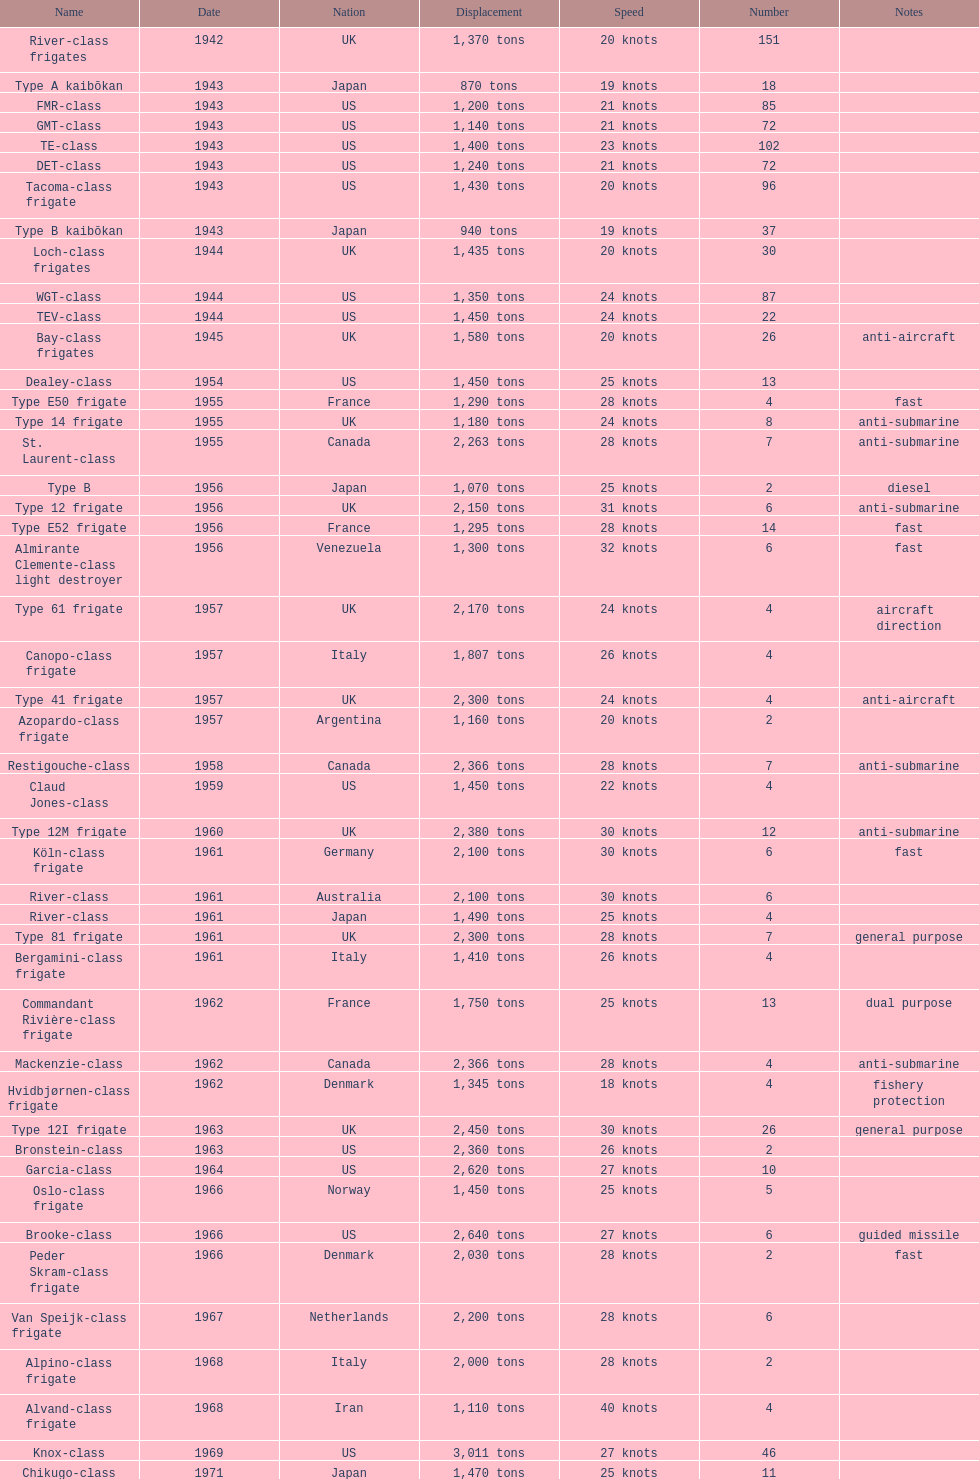Help me parse the entirety of this table. {'header': ['Name', 'Date', 'Nation', 'Displacement', 'Speed', 'Number', 'Notes'], 'rows': [['River-class frigates', '1942', 'UK', '1,370 tons', '20 knots', '151', ''], ['Type A kaibōkan', '1943', 'Japan', '870 tons', '19 knots', '18', ''], ['FMR-class', '1943', 'US', '1,200 tons', '21 knots', '85', ''], ['GMT-class', '1943', 'US', '1,140 tons', '21 knots', '72', ''], ['TE-class', '1943', 'US', '1,400 tons', '23 knots', '102', ''], ['DET-class', '1943', 'US', '1,240 tons', '21 knots', '72', ''], ['Tacoma-class frigate', '1943', 'US', '1,430 tons', '20 knots', '96', ''], ['Type B kaibōkan', '1943', 'Japan', '940 tons', '19 knots', '37', ''], ['Loch-class frigates', '1944', 'UK', '1,435 tons', '20 knots', '30', ''], ['WGT-class', '1944', 'US', '1,350 tons', '24 knots', '87', ''], ['TEV-class', '1944', 'US', '1,450 tons', '24 knots', '22', ''], ['Bay-class frigates', '1945', 'UK', '1,580 tons', '20 knots', '26', 'anti-aircraft'], ['Dealey-class', '1954', 'US', '1,450 tons', '25 knots', '13', ''], ['Type E50 frigate', '1955', 'France', '1,290 tons', '28 knots', '4', 'fast'], ['Type 14 frigate', '1955', 'UK', '1,180 tons', '24 knots', '8', 'anti-submarine'], ['St. Laurent-class', '1955', 'Canada', '2,263 tons', '28 knots', '7', 'anti-submarine'], ['Type B', '1956', 'Japan', '1,070 tons', '25 knots', '2', 'diesel'], ['Type 12 frigate', '1956', 'UK', '2,150 tons', '31 knots', '6', 'anti-submarine'], ['Type E52 frigate', '1956', 'France', '1,295 tons', '28 knots', '14', 'fast'], ['Almirante Clemente-class light destroyer', '1956', 'Venezuela', '1,300 tons', '32 knots', '6', 'fast'], ['Type 61 frigate', '1957', 'UK', '2,170 tons', '24 knots', '4', 'aircraft direction'], ['Canopo-class frigate', '1957', 'Italy', '1,807 tons', '26 knots', '4', ''], ['Type 41 frigate', '1957', 'UK', '2,300 tons', '24 knots', '4', 'anti-aircraft'], ['Azopardo-class frigate', '1957', 'Argentina', '1,160 tons', '20 knots', '2', ''], ['Restigouche-class', '1958', 'Canada', '2,366 tons', '28 knots', '7', 'anti-submarine'], ['Claud Jones-class', '1959', 'US', '1,450 tons', '22 knots', '4', ''], ['Type 12M frigate', '1960', 'UK', '2,380 tons', '30 knots', '12', 'anti-submarine'], ['Köln-class frigate', '1961', 'Germany', '2,100 tons', '30 knots', '6', 'fast'], ['River-class', '1961', 'Australia', '2,100 tons', '30 knots', '6', ''], ['River-class', '1961', 'Japan', '1,490 tons', '25 knots', '4', ''], ['Type 81 frigate', '1961', 'UK', '2,300 tons', '28 knots', '7', 'general purpose'], ['Bergamini-class frigate', '1961', 'Italy', '1,410 tons', '26 knots', '4', ''], ['Commandant Rivière-class frigate', '1962', 'France', '1,750 tons', '25 knots', '13', 'dual purpose'], ['Mackenzie-class', '1962', 'Canada', '2,366 tons', '28 knots', '4', 'anti-submarine'], ['Hvidbjørnen-class frigate', '1962', 'Denmark', '1,345 tons', '18 knots', '4', 'fishery protection'], ['Type 12I frigate', '1963', 'UK', '2,450 tons', '30 knots', '26', 'general purpose'], ['Bronstein-class', '1963', 'US', '2,360 tons', '26 knots', '2', ''], ['Garcia-class', '1964', 'US', '2,620 tons', '27 knots', '10', ''], ['Oslo-class frigate', '1966', 'Norway', '1,450 tons', '25 knots', '5', ''], ['Brooke-class', '1966', 'US', '2,640 tons', '27 knots', '6', 'guided missile'], ['Peder Skram-class frigate', '1966', 'Denmark', '2,030 tons', '28 knots', '2', 'fast'], ['Van Speijk-class frigate', '1967', 'Netherlands', '2,200 tons', '28 knots', '6', ''], ['Alpino-class frigate', '1968', 'Italy', '2,000 tons', '28 knots', '2', ''], ['Alvand-class frigate', '1968', 'Iran', '1,110 tons', '40 knots', '4', ''], ['Knox-class', '1969', 'US', '3,011 tons', '27 knots', '46', ''], ['Chikugo-class', '1971', 'Japan', '1,470 tons', '25 knots', '11', '']]} Which name is associated with the greatest displacement? Knox-class. 